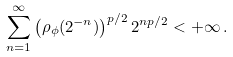<formula> <loc_0><loc_0><loc_500><loc_500>\sum _ { n = 1 } ^ { \infty } \left ( \rho _ { \phi } ( 2 ^ { - n } ) \right ) ^ { p / 2 } 2 ^ { n p / 2 } < + \infty \, .</formula> 